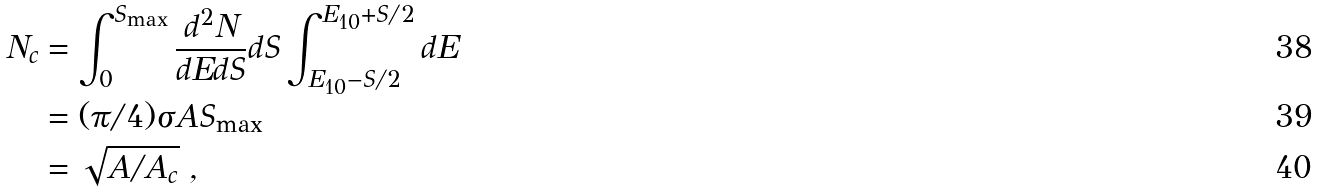Convert formula to latex. <formula><loc_0><loc_0><loc_500><loc_500>N _ { c } & = \int _ { 0 } ^ { S _ { \max } } \frac { d ^ { 2 } N } { d E d S } d S \int _ { E _ { 1 0 } - S / 2 } ^ { E _ { 1 0 } + S / 2 } d E \\ & = ( \pi / 4 ) \sigma A S _ { \max } \\ & = \sqrt { A / A _ { c } } \ ,</formula> 